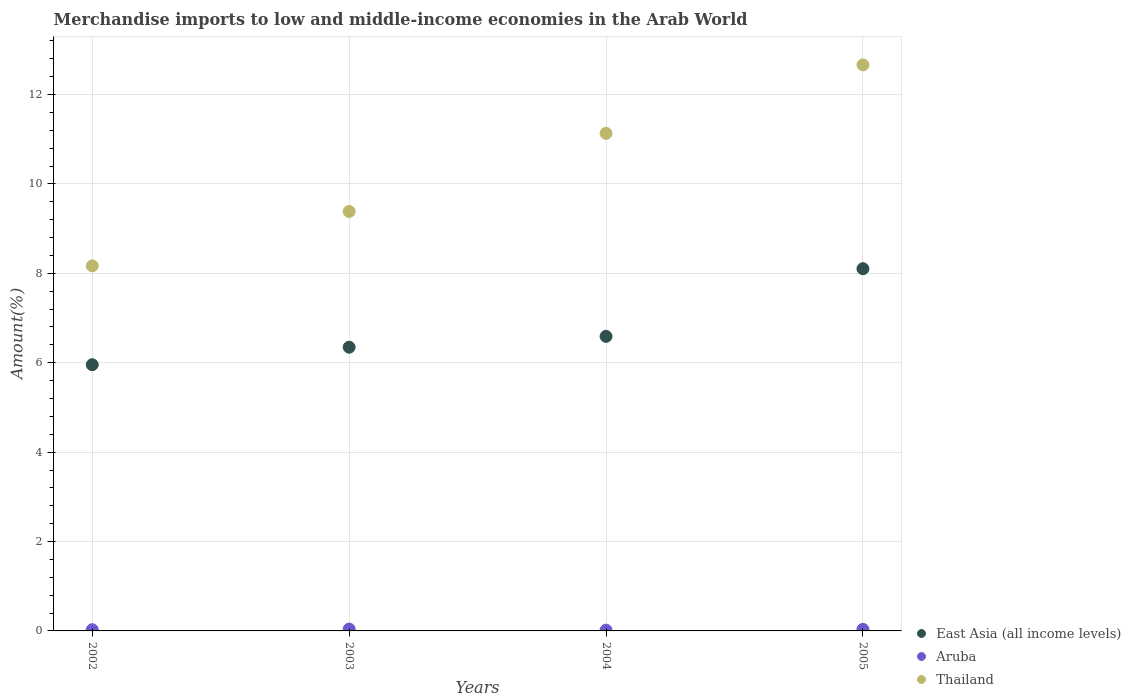What is the percentage of amount earned from merchandise imports in Aruba in 2004?
Offer a terse response. 0.02. Across all years, what is the maximum percentage of amount earned from merchandise imports in Aruba?
Your answer should be very brief. 0.04. Across all years, what is the minimum percentage of amount earned from merchandise imports in East Asia (all income levels)?
Give a very brief answer. 5.96. In which year was the percentage of amount earned from merchandise imports in East Asia (all income levels) maximum?
Your answer should be compact. 2005. In which year was the percentage of amount earned from merchandise imports in Thailand minimum?
Your answer should be compact. 2002. What is the total percentage of amount earned from merchandise imports in Thailand in the graph?
Offer a very short reply. 41.35. What is the difference between the percentage of amount earned from merchandise imports in East Asia (all income levels) in 2002 and that in 2005?
Offer a terse response. -2.15. What is the difference between the percentage of amount earned from merchandise imports in Aruba in 2002 and the percentage of amount earned from merchandise imports in East Asia (all income levels) in 2005?
Ensure brevity in your answer.  -8.08. What is the average percentage of amount earned from merchandise imports in Aruba per year?
Your answer should be very brief. 0.03. In the year 2005, what is the difference between the percentage of amount earned from merchandise imports in Thailand and percentage of amount earned from merchandise imports in East Asia (all income levels)?
Keep it short and to the point. 4.56. In how many years, is the percentage of amount earned from merchandise imports in Aruba greater than 1.6 %?
Keep it short and to the point. 0. What is the ratio of the percentage of amount earned from merchandise imports in Aruba in 2004 to that in 2005?
Offer a terse response. 0.51. What is the difference between the highest and the second highest percentage of amount earned from merchandise imports in East Asia (all income levels)?
Offer a terse response. 1.51. What is the difference between the highest and the lowest percentage of amount earned from merchandise imports in Aruba?
Your answer should be very brief. 0.02. In how many years, is the percentage of amount earned from merchandise imports in Thailand greater than the average percentage of amount earned from merchandise imports in Thailand taken over all years?
Provide a succinct answer. 2. Is the sum of the percentage of amount earned from merchandise imports in East Asia (all income levels) in 2003 and 2004 greater than the maximum percentage of amount earned from merchandise imports in Aruba across all years?
Ensure brevity in your answer.  Yes. Is the percentage of amount earned from merchandise imports in Thailand strictly greater than the percentage of amount earned from merchandise imports in East Asia (all income levels) over the years?
Keep it short and to the point. Yes. Is the percentage of amount earned from merchandise imports in Aruba strictly less than the percentage of amount earned from merchandise imports in East Asia (all income levels) over the years?
Give a very brief answer. Yes. How many years are there in the graph?
Offer a terse response. 4. What is the difference between two consecutive major ticks on the Y-axis?
Your response must be concise. 2. Are the values on the major ticks of Y-axis written in scientific E-notation?
Provide a succinct answer. No. Does the graph contain any zero values?
Give a very brief answer. No. Where does the legend appear in the graph?
Offer a terse response. Bottom right. What is the title of the graph?
Ensure brevity in your answer.  Merchandise imports to low and middle-income economies in the Arab World. Does "Belgium" appear as one of the legend labels in the graph?
Offer a very short reply. No. What is the label or title of the X-axis?
Your answer should be compact. Years. What is the label or title of the Y-axis?
Ensure brevity in your answer.  Amount(%). What is the Amount(%) in East Asia (all income levels) in 2002?
Offer a very short reply. 5.96. What is the Amount(%) of Aruba in 2002?
Give a very brief answer. 0.03. What is the Amount(%) of Thailand in 2002?
Keep it short and to the point. 8.17. What is the Amount(%) of East Asia (all income levels) in 2003?
Offer a terse response. 6.35. What is the Amount(%) in Aruba in 2003?
Keep it short and to the point. 0.04. What is the Amount(%) in Thailand in 2003?
Give a very brief answer. 9.38. What is the Amount(%) in East Asia (all income levels) in 2004?
Offer a very short reply. 6.59. What is the Amount(%) in Aruba in 2004?
Provide a short and direct response. 0.02. What is the Amount(%) in Thailand in 2004?
Your answer should be very brief. 11.13. What is the Amount(%) of East Asia (all income levels) in 2005?
Give a very brief answer. 8.1. What is the Amount(%) of Aruba in 2005?
Provide a succinct answer. 0.03. What is the Amount(%) of Thailand in 2005?
Your response must be concise. 12.66. Across all years, what is the maximum Amount(%) in East Asia (all income levels)?
Offer a terse response. 8.1. Across all years, what is the maximum Amount(%) in Aruba?
Your response must be concise. 0.04. Across all years, what is the maximum Amount(%) of Thailand?
Offer a very short reply. 12.66. Across all years, what is the minimum Amount(%) in East Asia (all income levels)?
Ensure brevity in your answer.  5.96. Across all years, what is the minimum Amount(%) in Aruba?
Make the answer very short. 0.02. Across all years, what is the minimum Amount(%) in Thailand?
Give a very brief answer. 8.17. What is the total Amount(%) of East Asia (all income levels) in the graph?
Ensure brevity in your answer.  27. What is the total Amount(%) of Aruba in the graph?
Make the answer very short. 0.12. What is the total Amount(%) in Thailand in the graph?
Give a very brief answer. 41.35. What is the difference between the Amount(%) in East Asia (all income levels) in 2002 and that in 2003?
Your response must be concise. -0.39. What is the difference between the Amount(%) of Aruba in 2002 and that in 2003?
Your answer should be very brief. -0.01. What is the difference between the Amount(%) of Thailand in 2002 and that in 2003?
Make the answer very short. -1.22. What is the difference between the Amount(%) in East Asia (all income levels) in 2002 and that in 2004?
Offer a terse response. -0.63. What is the difference between the Amount(%) in Aruba in 2002 and that in 2004?
Your answer should be compact. 0.01. What is the difference between the Amount(%) of Thailand in 2002 and that in 2004?
Offer a terse response. -2.96. What is the difference between the Amount(%) of East Asia (all income levels) in 2002 and that in 2005?
Your answer should be very brief. -2.15. What is the difference between the Amount(%) of Aruba in 2002 and that in 2005?
Keep it short and to the point. -0.01. What is the difference between the Amount(%) in Thailand in 2002 and that in 2005?
Offer a very short reply. -4.5. What is the difference between the Amount(%) of East Asia (all income levels) in 2003 and that in 2004?
Give a very brief answer. -0.24. What is the difference between the Amount(%) in Aruba in 2003 and that in 2004?
Offer a terse response. 0.02. What is the difference between the Amount(%) in Thailand in 2003 and that in 2004?
Provide a short and direct response. -1.75. What is the difference between the Amount(%) in East Asia (all income levels) in 2003 and that in 2005?
Keep it short and to the point. -1.76. What is the difference between the Amount(%) of Aruba in 2003 and that in 2005?
Your answer should be very brief. 0.01. What is the difference between the Amount(%) of Thailand in 2003 and that in 2005?
Provide a succinct answer. -3.28. What is the difference between the Amount(%) of East Asia (all income levels) in 2004 and that in 2005?
Provide a short and direct response. -1.51. What is the difference between the Amount(%) of Aruba in 2004 and that in 2005?
Offer a very short reply. -0.02. What is the difference between the Amount(%) of Thailand in 2004 and that in 2005?
Provide a succinct answer. -1.53. What is the difference between the Amount(%) of East Asia (all income levels) in 2002 and the Amount(%) of Aruba in 2003?
Keep it short and to the point. 5.91. What is the difference between the Amount(%) in East Asia (all income levels) in 2002 and the Amount(%) in Thailand in 2003?
Ensure brevity in your answer.  -3.43. What is the difference between the Amount(%) in Aruba in 2002 and the Amount(%) in Thailand in 2003?
Provide a succinct answer. -9.36. What is the difference between the Amount(%) of East Asia (all income levels) in 2002 and the Amount(%) of Aruba in 2004?
Make the answer very short. 5.94. What is the difference between the Amount(%) in East Asia (all income levels) in 2002 and the Amount(%) in Thailand in 2004?
Keep it short and to the point. -5.18. What is the difference between the Amount(%) in Aruba in 2002 and the Amount(%) in Thailand in 2004?
Provide a succinct answer. -11.1. What is the difference between the Amount(%) of East Asia (all income levels) in 2002 and the Amount(%) of Aruba in 2005?
Make the answer very short. 5.92. What is the difference between the Amount(%) of East Asia (all income levels) in 2002 and the Amount(%) of Thailand in 2005?
Provide a succinct answer. -6.71. What is the difference between the Amount(%) in Aruba in 2002 and the Amount(%) in Thailand in 2005?
Make the answer very short. -12.64. What is the difference between the Amount(%) of East Asia (all income levels) in 2003 and the Amount(%) of Aruba in 2004?
Offer a terse response. 6.33. What is the difference between the Amount(%) of East Asia (all income levels) in 2003 and the Amount(%) of Thailand in 2004?
Make the answer very short. -4.78. What is the difference between the Amount(%) in Aruba in 2003 and the Amount(%) in Thailand in 2004?
Make the answer very short. -11.09. What is the difference between the Amount(%) in East Asia (all income levels) in 2003 and the Amount(%) in Aruba in 2005?
Offer a terse response. 6.31. What is the difference between the Amount(%) in East Asia (all income levels) in 2003 and the Amount(%) in Thailand in 2005?
Give a very brief answer. -6.32. What is the difference between the Amount(%) in Aruba in 2003 and the Amount(%) in Thailand in 2005?
Offer a terse response. -12.62. What is the difference between the Amount(%) of East Asia (all income levels) in 2004 and the Amount(%) of Aruba in 2005?
Provide a short and direct response. 6.56. What is the difference between the Amount(%) of East Asia (all income levels) in 2004 and the Amount(%) of Thailand in 2005?
Make the answer very short. -6.07. What is the difference between the Amount(%) in Aruba in 2004 and the Amount(%) in Thailand in 2005?
Offer a terse response. -12.65. What is the average Amount(%) of East Asia (all income levels) per year?
Your answer should be compact. 6.75. What is the average Amount(%) of Thailand per year?
Ensure brevity in your answer.  10.34. In the year 2002, what is the difference between the Amount(%) in East Asia (all income levels) and Amount(%) in Aruba?
Your answer should be very brief. 5.93. In the year 2002, what is the difference between the Amount(%) of East Asia (all income levels) and Amount(%) of Thailand?
Give a very brief answer. -2.21. In the year 2002, what is the difference between the Amount(%) of Aruba and Amount(%) of Thailand?
Your answer should be compact. -8.14. In the year 2003, what is the difference between the Amount(%) of East Asia (all income levels) and Amount(%) of Aruba?
Make the answer very short. 6.31. In the year 2003, what is the difference between the Amount(%) in East Asia (all income levels) and Amount(%) in Thailand?
Your response must be concise. -3.04. In the year 2003, what is the difference between the Amount(%) in Aruba and Amount(%) in Thailand?
Keep it short and to the point. -9.34. In the year 2004, what is the difference between the Amount(%) in East Asia (all income levels) and Amount(%) in Aruba?
Provide a short and direct response. 6.57. In the year 2004, what is the difference between the Amount(%) of East Asia (all income levels) and Amount(%) of Thailand?
Make the answer very short. -4.54. In the year 2004, what is the difference between the Amount(%) of Aruba and Amount(%) of Thailand?
Offer a terse response. -11.11. In the year 2005, what is the difference between the Amount(%) in East Asia (all income levels) and Amount(%) in Aruba?
Offer a very short reply. 8.07. In the year 2005, what is the difference between the Amount(%) in East Asia (all income levels) and Amount(%) in Thailand?
Keep it short and to the point. -4.56. In the year 2005, what is the difference between the Amount(%) of Aruba and Amount(%) of Thailand?
Your answer should be very brief. -12.63. What is the ratio of the Amount(%) of East Asia (all income levels) in 2002 to that in 2003?
Your answer should be compact. 0.94. What is the ratio of the Amount(%) of Aruba in 2002 to that in 2003?
Give a very brief answer. 0.65. What is the ratio of the Amount(%) of Thailand in 2002 to that in 2003?
Make the answer very short. 0.87. What is the ratio of the Amount(%) in East Asia (all income levels) in 2002 to that in 2004?
Give a very brief answer. 0.9. What is the ratio of the Amount(%) of Aruba in 2002 to that in 2004?
Offer a terse response. 1.55. What is the ratio of the Amount(%) in Thailand in 2002 to that in 2004?
Offer a very short reply. 0.73. What is the ratio of the Amount(%) in East Asia (all income levels) in 2002 to that in 2005?
Ensure brevity in your answer.  0.73. What is the ratio of the Amount(%) of Aruba in 2002 to that in 2005?
Give a very brief answer. 0.79. What is the ratio of the Amount(%) in Thailand in 2002 to that in 2005?
Your response must be concise. 0.64. What is the ratio of the Amount(%) in East Asia (all income levels) in 2003 to that in 2004?
Offer a very short reply. 0.96. What is the ratio of the Amount(%) of Aruba in 2003 to that in 2004?
Keep it short and to the point. 2.37. What is the ratio of the Amount(%) in Thailand in 2003 to that in 2004?
Your answer should be very brief. 0.84. What is the ratio of the Amount(%) of East Asia (all income levels) in 2003 to that in 2005?
Your answer should be compact. 0.78. What is the ratio of the Amount(%) of Aruba in 2003 to that in 2005?
Ensure brevity in your answer.  1.21. What is the ratio of the Amount(%) of Thailand in 2003 to that in 2005?
Give a very brief answer. 0.74. What is the ratio of the Amount(%) of East Asia (all income levels) in 2004 to that in 2005?
Make the answer very short. 0.81. What is the ratio of the Amount(%) in Aruba in 2004 to that in 2005?
Give a very brief answer. 0.51. What is the ratio of the Amount(%) of Thailand in 2004 to that in 2005?
Provide a short and direct response. 0.88. What is the difference between the highest and the second highest Amount(%) in East Asia (all income levels)?
Offer a terse response. 1.51. What is the difference between the highest and the second highest Amount(%) of Aruba?
Your answer should be compact. 0.01. What is the difference between the highest and the second highest Amount(%) in Thailand?
Keep it short and to the point. 1.53. What is the difference between the highest and the lowest Amount(%) of East Asia (all income levels)?
Give a very brief answer. 2.15. What is the difference between the highest and the lowest Amount(%) in Aruba?
Make the answer very short. 0.02. What is the difference between the highest and the lowest Amount(%) of Thailand?
Provide a short and direct response. 4.5. 